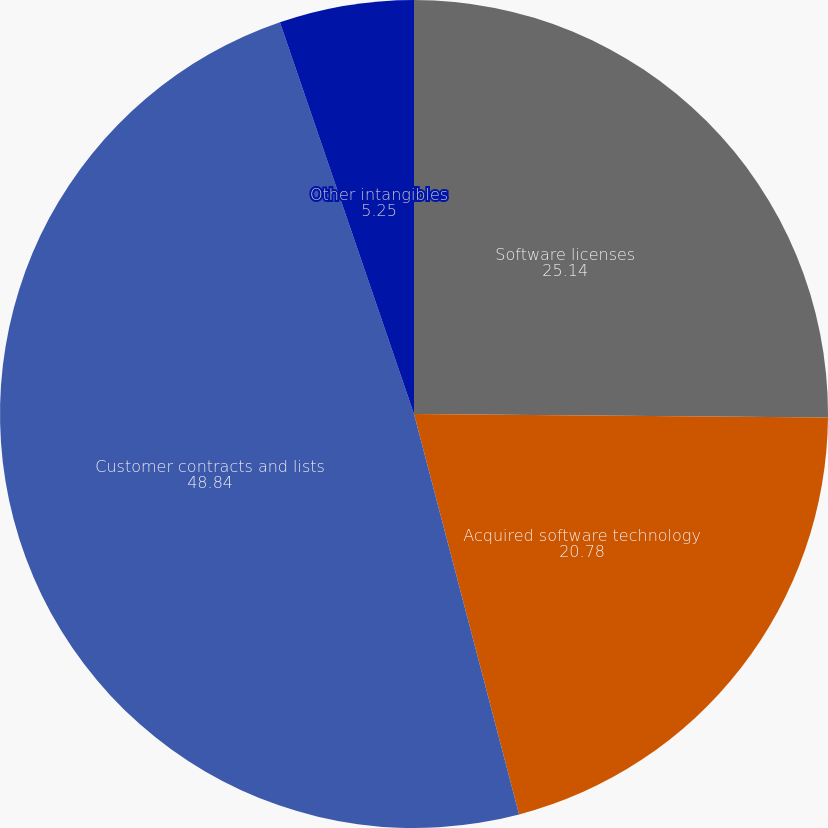Convert chart to OTSL. <chart><loc_0><loc_0><loc_500><loc_500><pie_chart><fcel>Software licenses<fcel>Acquired software technology<fcel>Customer contracts and lists<fcel>Other intangibles<nl><fcel>25.14%<fcel>20.78%<fcel>48.84%<fcel>5.25%<nl></chart> 